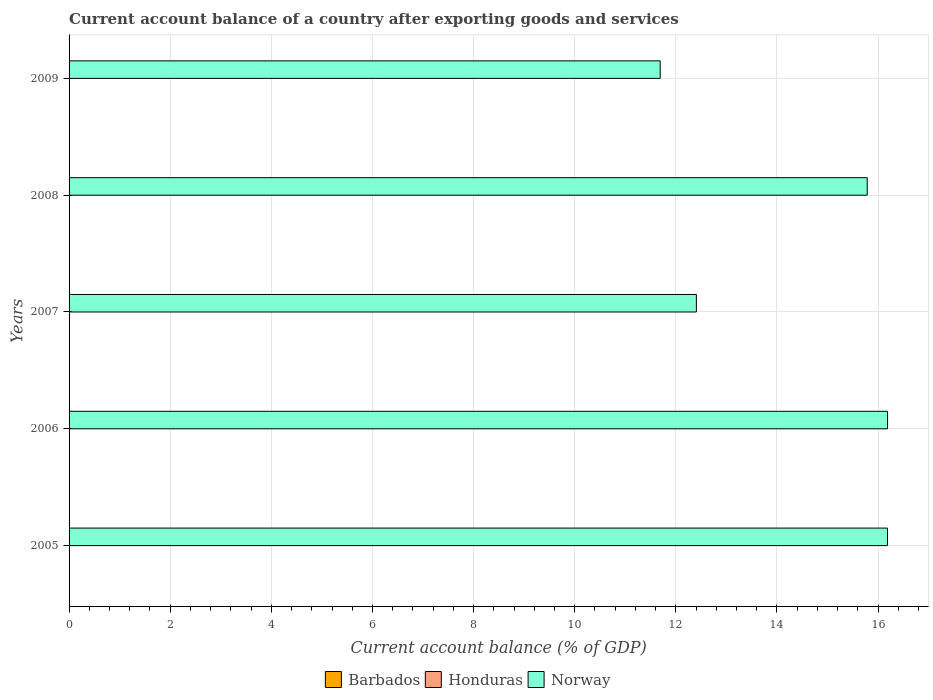Are the number of bars per tick equal to the number of legend labels?
Offer a terse response. No. Are the number of bars on each tick of the Y-axis equal?
Your answer should be very brief. Yes. How many bars are there on the 4th tick from the bottom?
Your answer should be compact. 1. What is the account balance in Honduras in 2006?
Provide a short and direct response. 0. Across all years, what is the maximum account balance in Norway?
Your answer should be very brief. 16.19. Across all years, what is the minimum account balance in Honduras?
Offer a very short reply. 0. In which year was the account balance in Norway maximum?
Your answer should be compact. 2006. What is the total account balance in Norway in the graph?
Your answer should be compact. 72.25. What is the difference between the account balance in Norway in 2005 and that in 2008?
Offer a terse response. 0.4. What is the difference between the account balance in Norway in 2006 and the account balance in Honduras in 2008?
Keep it short and to the point. 16.19. What is the average account balance in Norway per year?
Give a very brief answer. 14.45. In how many years, is the account balance in Barbados greater than 3.2 %?
Give a very brief answer. 0. What is the difference between the highest and the second highest account balance in Norway?
Your response must be concise. 0. What is the difference between the highest and the lowest account balance in Norway?
Your response must be concise. 4.5. In how many years, is the account balance in Barbados greater than the average account balance in Barbados taken over all years?
Give a very brief answer. 0. Is the sum of the account balance in Norway in 2005 and 2006 greater than the maximum account balance in Honduras across all years?
Make the answer very short. Yes. Is it the case that in every year, the sum of the account balance in Barbados and account balance in Norway is greater than the account balance in Honduras?
Provide a succinct answer. Yes. How many bars are there?
Offer a very short reply. 5. Are all the bars in the graph horizontal?
Offer a terse response. Yes. How many years are there in the graph?
Ensure brevity in your answer.  5. Are the values on the major ticks of X-axis written in scientific E-notation?
Your response must be concise. No. Does the graph contain any zero values?
Your answer should be very brief. Yes. Does the graph contain grids?
Offer a very short reply. Yes. Where does the legend appear in the graph?
Make the answer very short. Bottom center. What is the title of the graph?
Offer a terse response. Current account balance of a country after exporting goods and services. Does "Tonga" appear as one of the legend labels in the graph?
Make the answer very short. No. What is the label or title of the X-axis?
Provide a short and direct response. Current account balance (% of GDP). What is the Current account balance (% of GDP) of Norway in 2005?
Your response must be concise. 16.19. What is the Current account balance (% of GDP) of Honduras in 2006?
Your answer should be very brief. 0. What is the Current account balance (% of GDP) of Norway in 2006?
Ensure brevity in your answer.  16.19. What is the Current account balance (% of GDP) in Barbados in 2007?
Your answer should be compact. 0. What is the Current account balance (% of GDP) of Honduras in 2007?
Your answer should be compact. 0. What is the Current account balance (% of GDP) of Norway in 2007?
Provide a succinct answer. 12.41. What is the Current account balance (% of GDP) of Norway in 2008?
Ensure brevity in your answer.  15.78. What is the Current account balance (% of GDP) in Honduras in 2009?
Offer a very short reply. 0. What is the Current account balance (% of GDP) in Norway in 2009?
Offer a terse response. 11.69. Across all years, what is the maximum Current account balance (% of GDP) of Norway?
Offer a very short reply. 16.19. Across all years, what is the minimum Current account balance (% of GDP) of Norway?
Keep it short and to the point. 11.69. What is the total Current account balance (% of GDP) in Barbados in the graph?
Keep it short and to the point. 0. What is the total Current account balance (% of GDP) of Norway in the graph?
Offer a terse response. 72.25. What is the difference between the Current account balance (% of GDP) in Norway in 2005 and that in 2006?
Ensure brevity in your answer.  -0. What is the difference between the Current account balance (% of GDP) in Norway in 2005 and that in 2007?
Keep it short and to the point. 3.78. What is the difference between the Current account balance (% of GDP) in Norway in 2005 and that in 2008?
Give a very brief answer. 0.4. What is the difference between the Current account balance (% of GDP) in Norway in 2005 and that in 2009?
Provide a short and direct response. 4.5. What is the difference between the Current account balance (% of GDP) of Norway in 2006 and that in 2007?
Give a very brief answer. 3.78. What is the difference between the Current account balance (% of GDP) of Norway in 2006 and that in 2008?
Give a very brief answer. 0.4. What is the difference between the Current account balance (% of GDP) of Norway in 2006 and that in 2009?
Provide a succinct answer. 4.5. What is the difference between the Current account balance (% of GDP) of Norway in 2007 and that in 2008?
Your answer should be very brief. -3.38. What is the difference between the Current account balance (% of GDP) in Norway in 2007 and that in 2009?
Your answer should be very brief. 0.72. What is the difference between the Current account balance (% of GDP) of Norway in 2008 and that in 2009?
Provide a succinct answer. 4.09. What is the average Current account balance (% of GDP) in Honduras per year?
Give a very brief answer. 0. What is the average Current account balance (% of GDP) in Norway per year?
Your response must be concise. 14.45. What is the ratio of the Current account balance (% of GDP) of Norway in 2005 to that in 2007?
Give a very brief answer. 1.3. What is the ratio of the Current account balance (% of GDP) in Norway in 2005 to that in 2008?
Give a very brief answer. 1.03. What is the ratio of the Current account balance (% of GDP) of Norway in 2005 to that in 2009?
Your response must be concise. 1.38. What is the ratio of the Current account balance (% of GDP) of Norway in 2006 to that in 2007?
Your response must be concise. 1.3. What is the ratio of the Current account balance (% of GDP) of Norway in 2006 to that in 2008?
Keep it short and to the point. 1.03. What is the ratio of the Current account balance (% of GDP) of Norway in 2006 to that in 2009?
Your answer should be very brief. 1.38. What is the ratio of the Current account balance (% of GDP) in Norway in 2007 to that in 2008?
Offer a very short reply. 0.79. What is the ratio of the Current account balance (% of GDP) of Norway in 2007 to that in 2009?
Ensure brevity in your answer.  1.06. What is the ratio of the Current account balance (% of GDP) of Norway in 2008 to that in 2009?
Keep it short and to the point. 1.35. What is the difference between the highest and the second highest Current account balance (% of GDP) in Norway?
Offer a very short reply. 0. What is the difference between the highest and the lowest Current account balance (% of GDP) in Norway?
Provide a succinct answer. 4.5. 